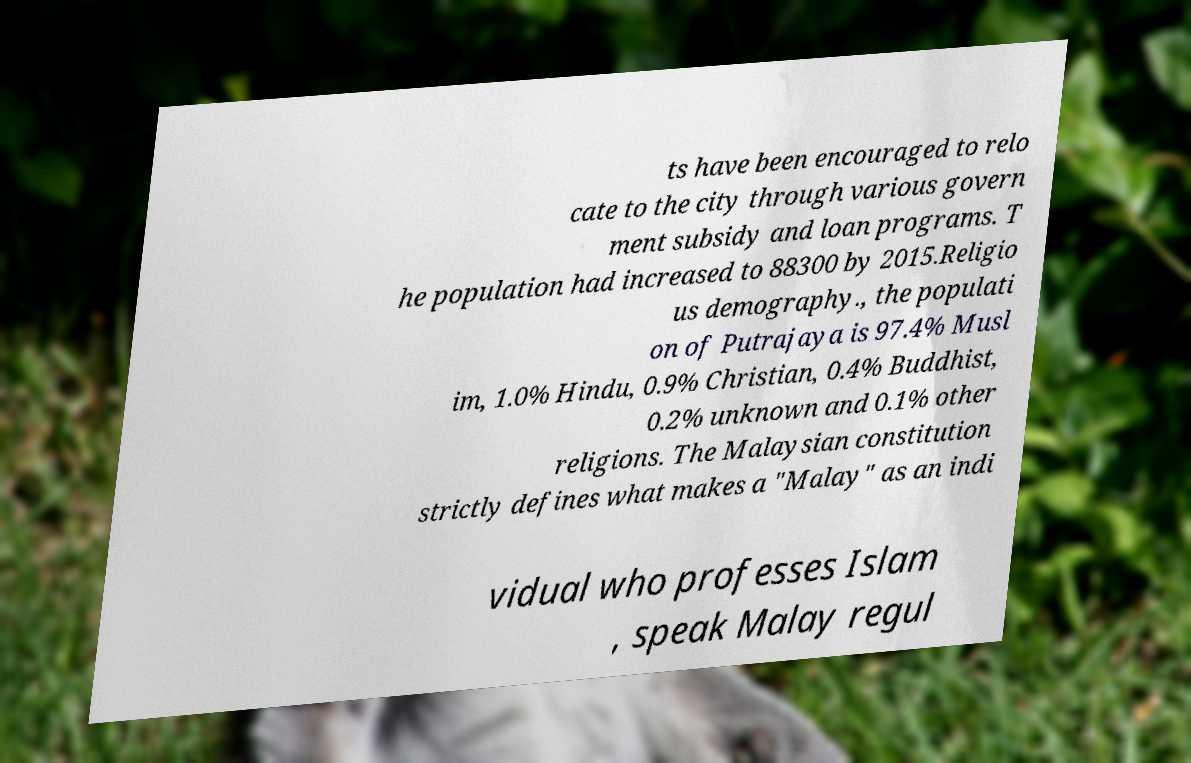I need the written content from this picture converted into text. Can you do that? ts have been encouraged to relo cate to the city through various govern ment subsidy and loan programs. T he population had increased to 88300 by 2015.Religio us demography., the populati on of Putrajaya is 97.4% Musl im, 1.0% Hindu, 0.9% Christian, 0.4% Buddhist, 0.2% unknown and 0.1% other religions. The Malaysian constitution strictly defines what makes a "Malay" as an indi vidual who professes Islam , speak Malay regul 